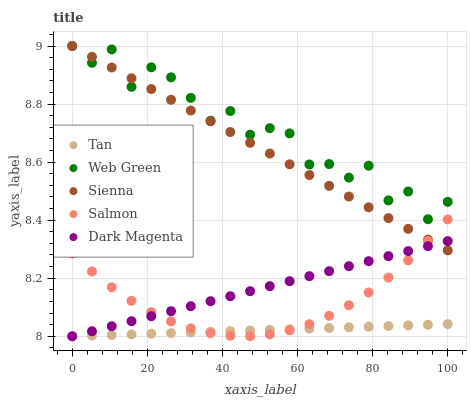Does Tan have the minimum area under the curve?
Answer yes or no. Yes. Does Web Green have the maximum area under the curve?
Answer yes or no. Yes. Does Salmon have the minimum area under the curve?
Answer yes or no. No. Does Salmon have the maximum area under the curve?
Answer yes or no. No. Is Dark Magenta the smoothest?
Answer yes or no. Yes. Is Web Green the roughest?
Answer yes or no. Yes. Is Tan the smoothest?
Answer yes or no. No. Is Tan the roughest?
Answer yes or no. No. Does Tan have the lowest value?
Answer yes or no. Yes. Does Salmon have the lowest value?
Answer yes or no. No. Does Web Green have the highest value?
Answer yes or no. Yes. Does Salmon have the highest value?
Answer yes or no. No. Is Tan less than Sienna?
Answer yes or no. Yes. Is Sienna greater than Tan?
Answer yes or no. Yes. Does Sienna intersect Dark Magenta?
Answer yes or no. Yes. Is Sienna less than Dark Magenta?
Answer yes or no. No. Is Sienna greater than Dark Magenta?
Answer yes or no. No. Does Tan intersect Sienna?
Answer yes or no. No. 